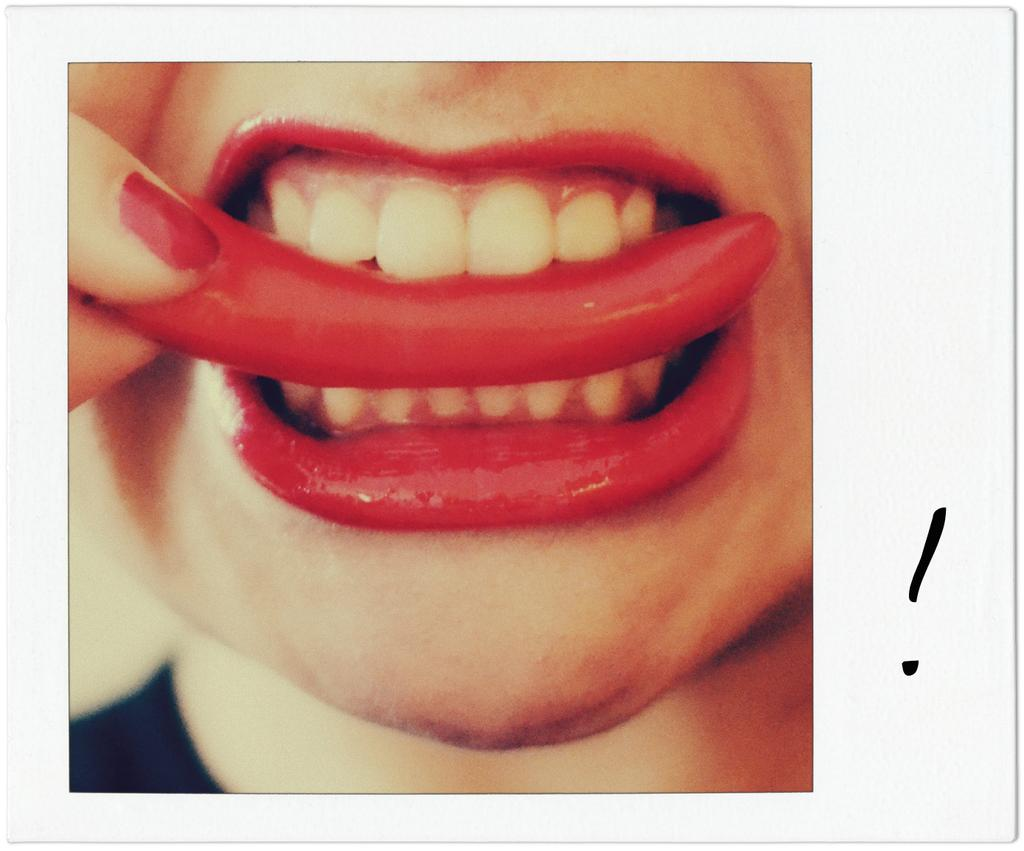What is in the person's mouth in the image? There is a chili in the person's mouth in the image. What type of comb is being used to style the person's hair in the image? There is no comb present in the image; it only shows a chili in the person's mouth. 